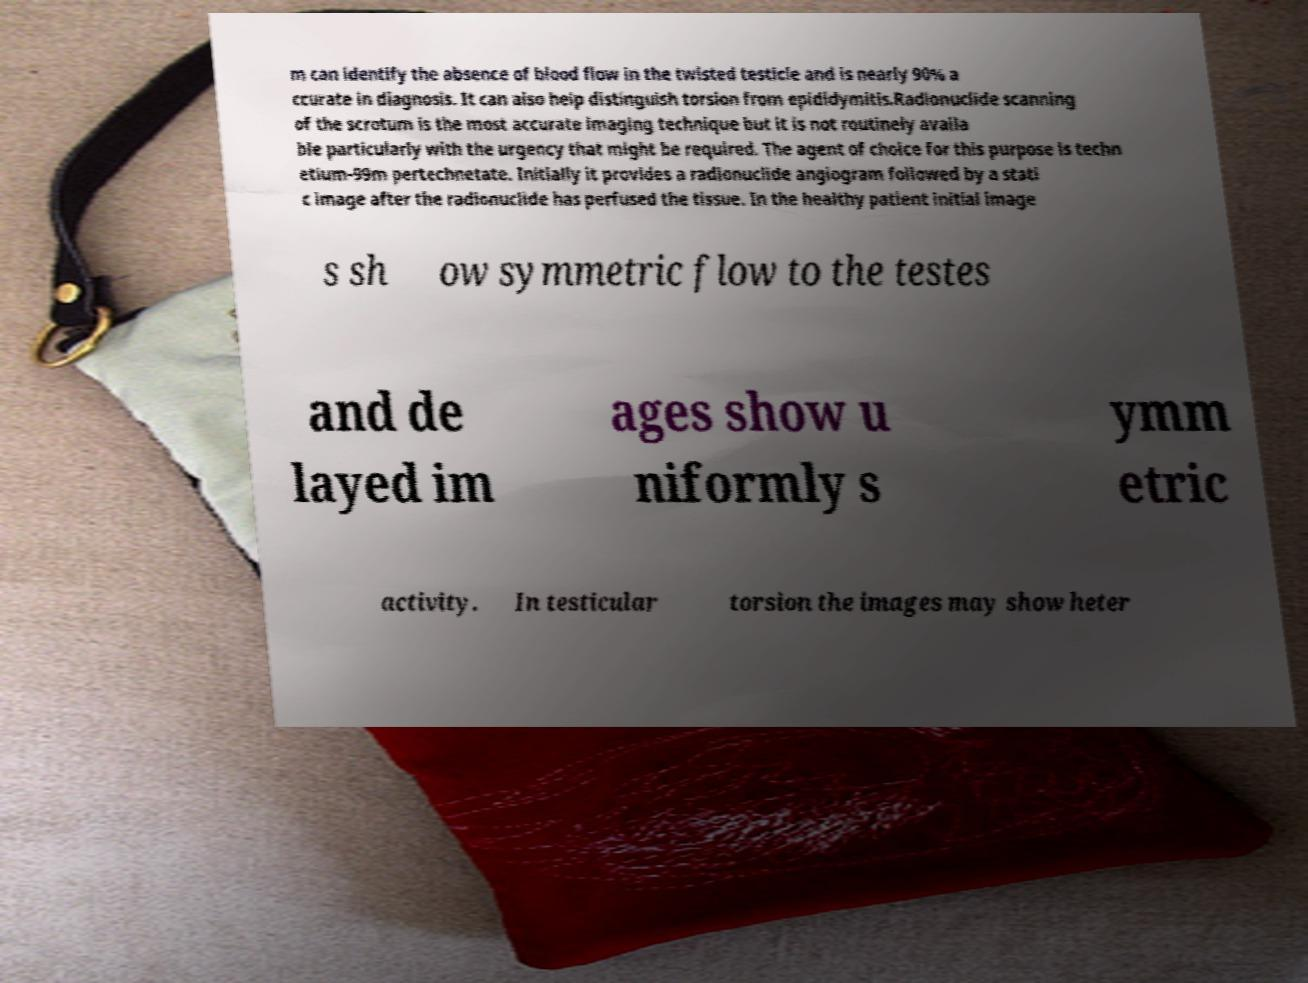Please identify and transcribe the text found in this image. m can identify the absence of blood flow in the twisted testicle and is nearly 90% a ccurate in diagnosis. It can also help distinguish torsion from epididymitis.Radionuclide scanning of the scrotum is the most accurate imaging technique but it is not routinely availa ble particularly with the urgency that might be required. The agent of choice for this purpose is techn etium-99m pertechnetate. Initially it provides a radionuclide angiogram followed by a stati c image after the radionuclide has perfused the tissue. In the healthy patient initial image s sh ow symmetric flow to the testes and de layed im ages show u niformly s ymm etric activity. In testicular torsion the images may show heter 